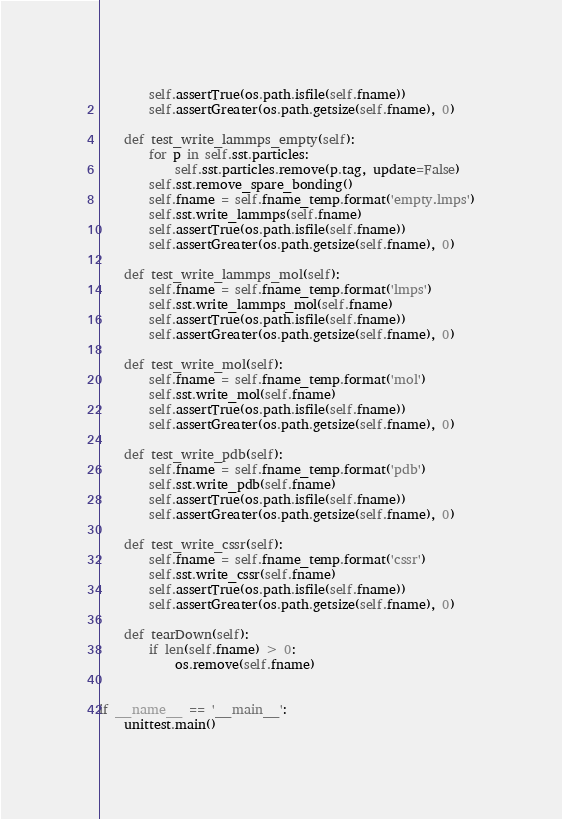Convert code to text. <code><loc_0><loc_0><loc_500><loc_500><_Python_>        self.assertTrue(os.path.isfile(self.fname))
        self.assertGreater(os.path.getsize(self.fname), 0)

    def test_write_lammps_empty(self):
        for p in self.sst.particles:
            self.sst.particles.remove(p.tag, update=False)
        self.sst.remove_spare_bonding()
        self.fname = self.fname_temp.format('empty.lmps')
        self.sst.write_lammps(self.fname)
        self.assertTrue(os.path.isfile(self.fname))
        self.assertGreater(os.path.getsize(self.fname), 0)

    def test_write_lammps_mol(self):
        self.fname = self.fname_temp.format('lmps')
        self.sst.write_lammps_mol(self.fname)
        self.assertTrue(os.path.isfile(self.fname))
        self.assertGreater(os.path.getsize(self.fname), 0)

    def test_write_mol(self):
        self.fname = self.fname_temp.format('mol')
        self.sst.write_mol(self.fname)
        self.assertTrue(os.path.isfile(self.fname))
        self.assertGreater(os.path.getsize(self.fname), 0)

    def test_write_pdb(self):
        self.fname = self.fname_temp.format('pdb')
        self.sst.write_pdb(self.fname)
        self.assertTrue(os.path.isfile(self.fname))
        self.assertGreater(os.path.getsize(self.fname), 0)

    def test_write_cssr(self):
        self.fname = self.fname_temp.format('cssr')
        self.sst.write_cssr(self.fname)
        self.assertTrue(os.path.isfile(self.fname))
        self.assertGreater(os.path.getsize(self.fname), 0)

    def tearDown(self):
        if len(self.fname) > 0:
            os.remove(self.fname)


if __name__ == '__main__':
    unittest.main()
</code> 